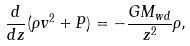<formula> <loc_0><loc_0><loc_500><loc_500>\frac { d } { d z } ( \rho v ^ { 2 } + P ) = - \frac { G M _ { w d } } { z ^ { 2 } } \rho ,</formula> 